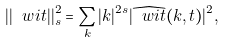<formula> <loc_0><loc_0><loc_500><loc_500>| | \ w i t | | ^ { 2 } _ { s } = \sum _ { k } | k | ^ { 2 s } | \widehat { \ w i t } ( k , t ) | ^ { 2 } ,</formula> 